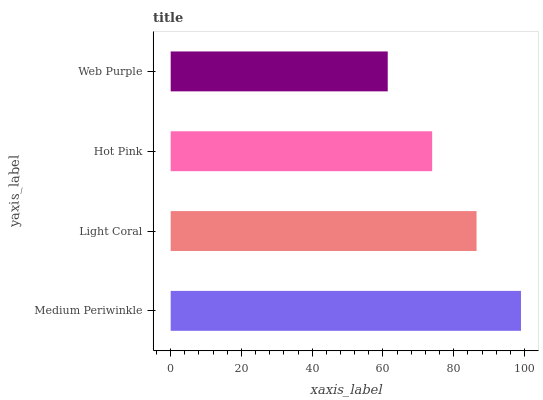Is Web Purple the minimum?
Answer yes or no. Yes. Is Medium Periwinkle the maximum?
Answer yes or no. Yes. Is Light Coral the minimum?
Answer yes or no. No. Is Light Coral the maximum?
Answer yes or no. No. Is Medium Periwinkle greater than Light Coral?
Answer yes or no. Yes. Is Light Coral less than Medium Periwinkle?
Answer yes or no. Yes. Is Light Coral greater than Medium Periwinkle?
Answer yes or no. No. Is Medium Periwinkle less than Light Coral?
Answer yes or no. No. Is Light Coral the high median?
Answer yes or no. Yes. Is Hot Pink the low median?
Answer yes or no. Yes. Is Medium Periwinkle the high median?
Answer yes or no. No. Is Light Coral the low median?
Answer yes or no. No. 